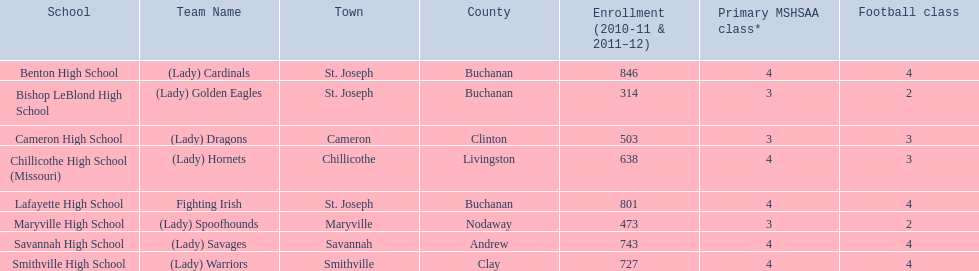What school has 3 football classes but only has 638 student enrollment? Chillicothe High School (Missouri). 